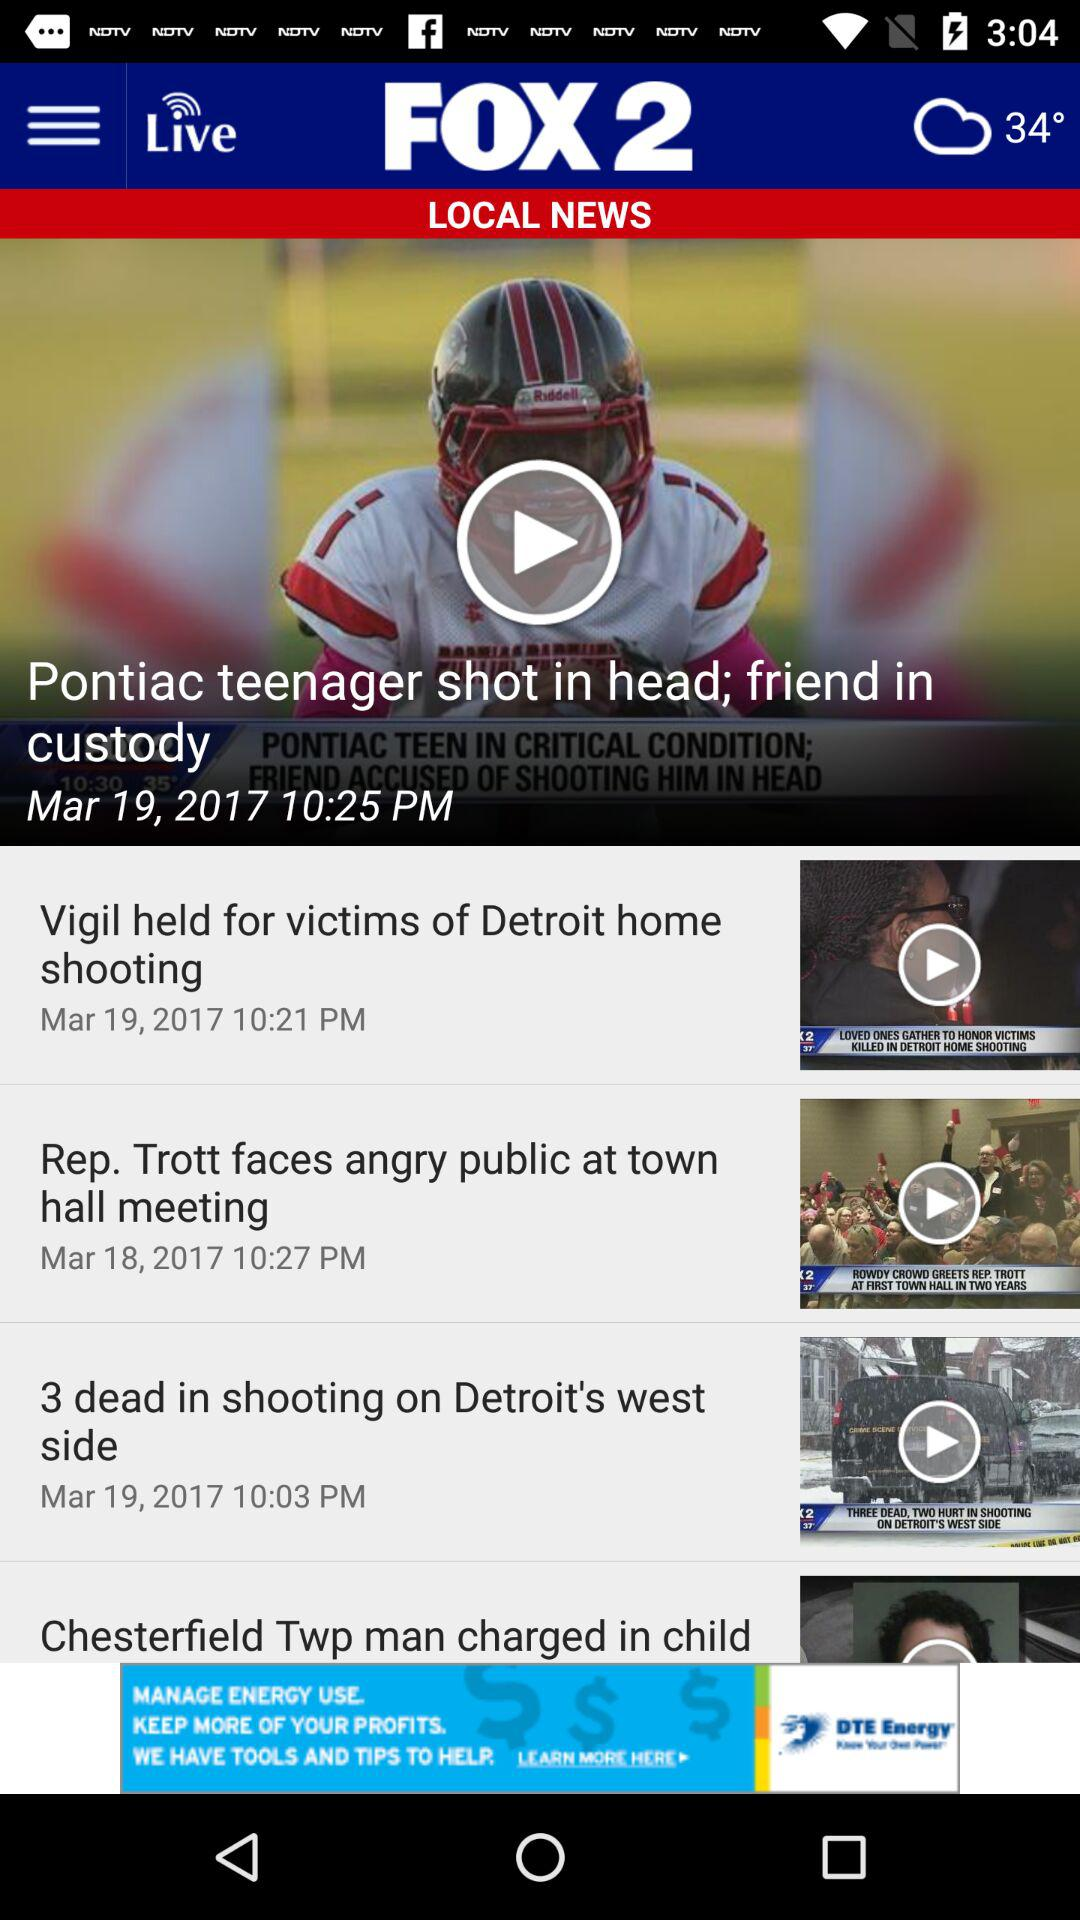What is the broadcast time of the news?
When the provided information is insufficient, respond with <no answer>. <no answer> 